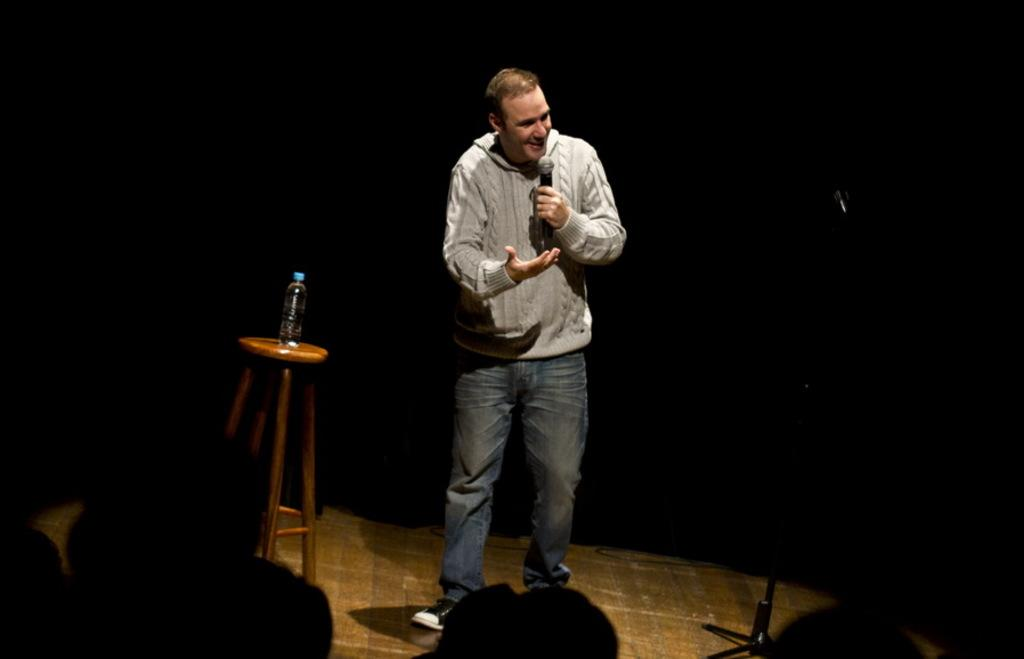What is the man in the image doing? The man is holding a mic in his hand and talking. What object is the man holding while talking? The man is holding a mic in his hand. What can be seen on the stool in the image? There is a bottle on a stool in the image. What is the condition of the background in the image? The background of the image is dark. Who is the man addressing while talking? There are people in front of the man, so he might be addressing them. What type of snails can be seen crawling on the man's shoes in the image? There are no snails present in the image, so it is not possible to determine what type of snails might be on the man's shoes. 